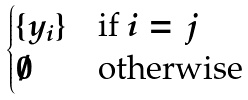Convert formula to latex. <formula><loc_0><loc_0><loc_500><loc_500>\begin{cases} \{ y _ { i } \} & \text {if $i=j$} \\ \emptyset & \text {otherwise} \end{cases}</formula> 